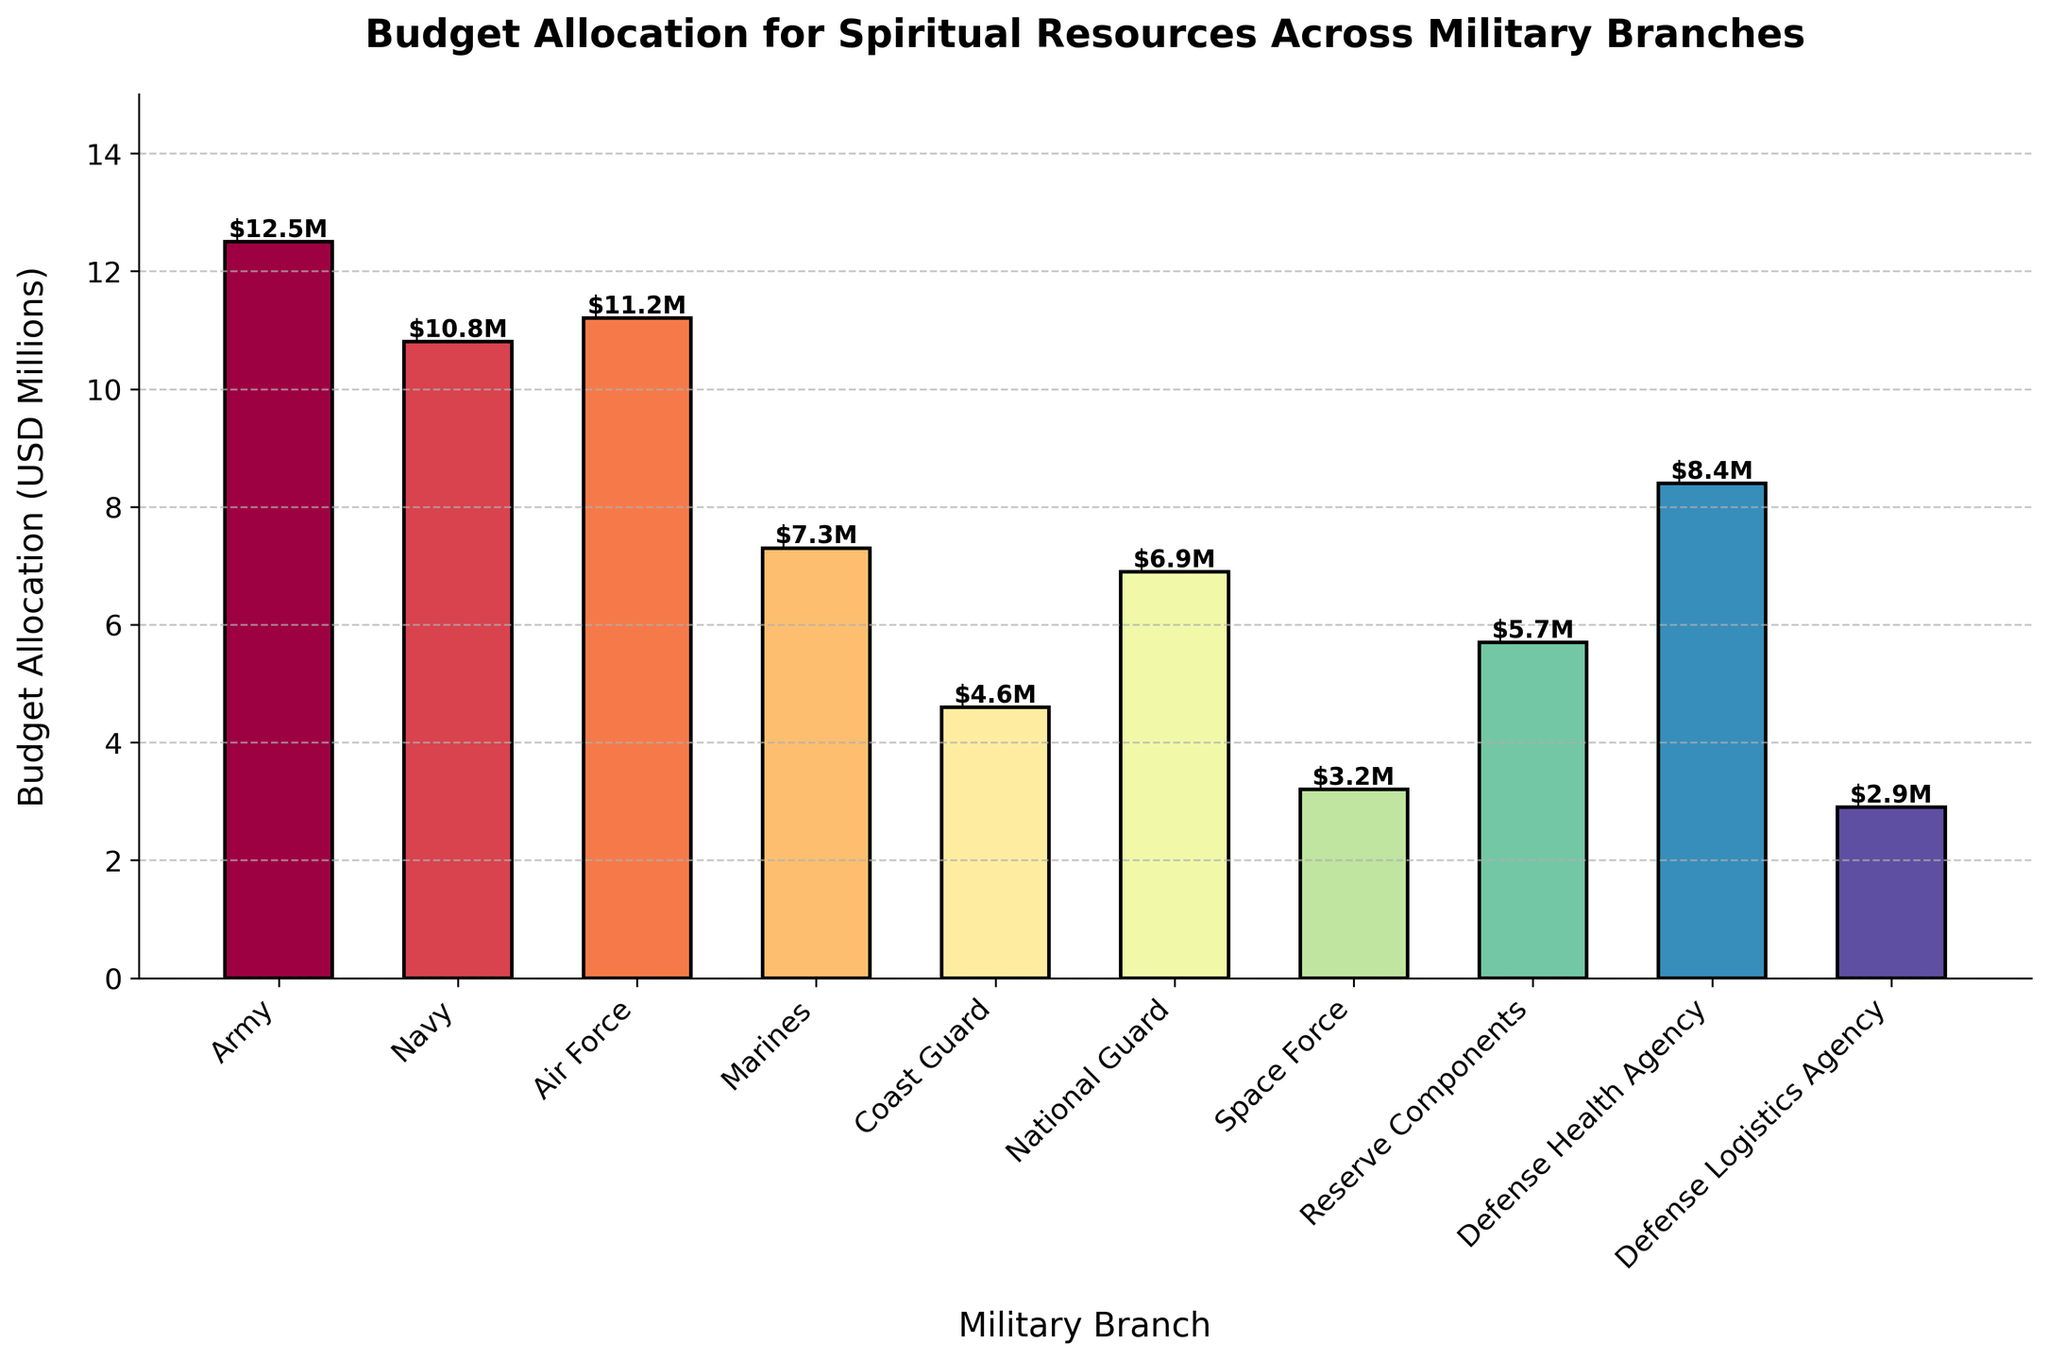Which military branch has the highest budget allocation for spiritual resources? The bar representing the Army is the tallest on the chart, indicating it has the highest budget allocation.
Answer: Army Which military branch has the lowest budget allocation for spiritual resources? The bar representing the Space Force is the shortest on the chart, indicating it has the lowest budget allocation.
Answer: Space Force What is the total budget allocation for the Army, Navy, and Air Force combined? Adding the budget allocations from the bars representing the Army (12.5M), Navy (10.8M), and Air Force (11.2M): 12.5 + 10.8 + 11.2 = 34.5M
Answer: 34.5M How much more budget does the Air Force have compared to the Marines? The Air Force has a budget of 11.2M and the Marines have 7.3M. The difference is calculated as 11.2 - 7.3 = 3.9M
Answer: 3.9M What is the average budget allocation for all military branches? Adding all budget allocations: 12.5 + 10.8 + 11.2 + 7.3 + 4.6 + 6.9 + 3.2 + 5.7 + 8.4 + 2.9 = 73.5M. Dividing by the number of branches (10): 73.5 / 10 = 7.35M
Answer: 7.35M Which military branch has a budget closest to the average budget allocation for all branches? The average budget allocation is 7.35M. By examining the chart, the National Guard with 6.9M is the closest.
Answer: National Guard Compare the budget allocation between the Coast Guard and National Guard. Which one is higher and by how much? The Coast Guard has 4.6M while the National Guard has 6.9M. The difference is 6.9 - 4.6 = 2.3M, with the National Guard having the higher budget.
Answer: National Guard by 2.3M Which two branches have the most similar budget allocations, and what are their budget amounts? The Air Force and the Navy have the most similar budget amounts of 11.2M and 10.8M, respectively, differing by only 0.4M.
Answer: Air Force and Navy What is the combined budget allocation for defense-related agencies (Defense Health Agency and Defense Logistics Agency)? Adding the budget allocations for Defense Health Agency (8.4M) and Defense Logistics Agency (2.9M): 8.4 + 2.9 = 11.3M
Answer: 11.3M Is the budget allocation for the Reserve Components greater than or less than the average budget allocation for all branches, and by how much? The budget for Reserve Components is 5.7M. The average budget allocation is 7.35M. The difference is 7.35 - 5.7 = 1.65M, so it is less by 1.65M.
Answer: Less by 1.65M 